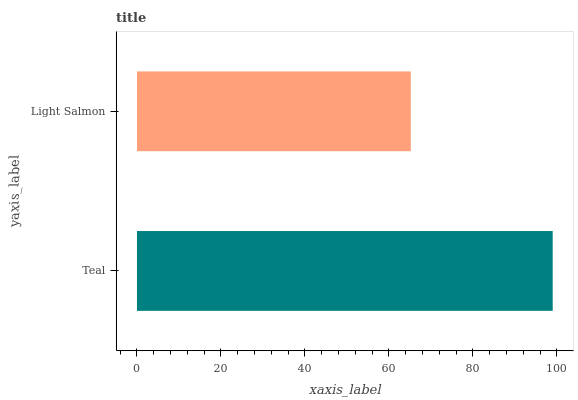Is Light Salmon the minimum?
Answer yes or no. Yes. Is Teal the maximum?
Answer yes or no. Yes. Is Light Salmon the maximum?
Answer yes or no. No. Is Teal greater than Light Salmon?
Answer yes or no. Yes. Is Light Salmon less than Teal?
Answer yes or no. Yes. Is Light Salmon greater than Teal?
Answer yes or no. No. Is Teal less than Light Salmon?
Answer yes or no. No. Is Teal the high median?
Answer yes or no. Yes. Is Light Salmon the low median?
Answer yes or no. Yes. Is Light Salmon the high median?
Answer yes or no. No. Is Teal the low median?
Answer yes or no. No. 